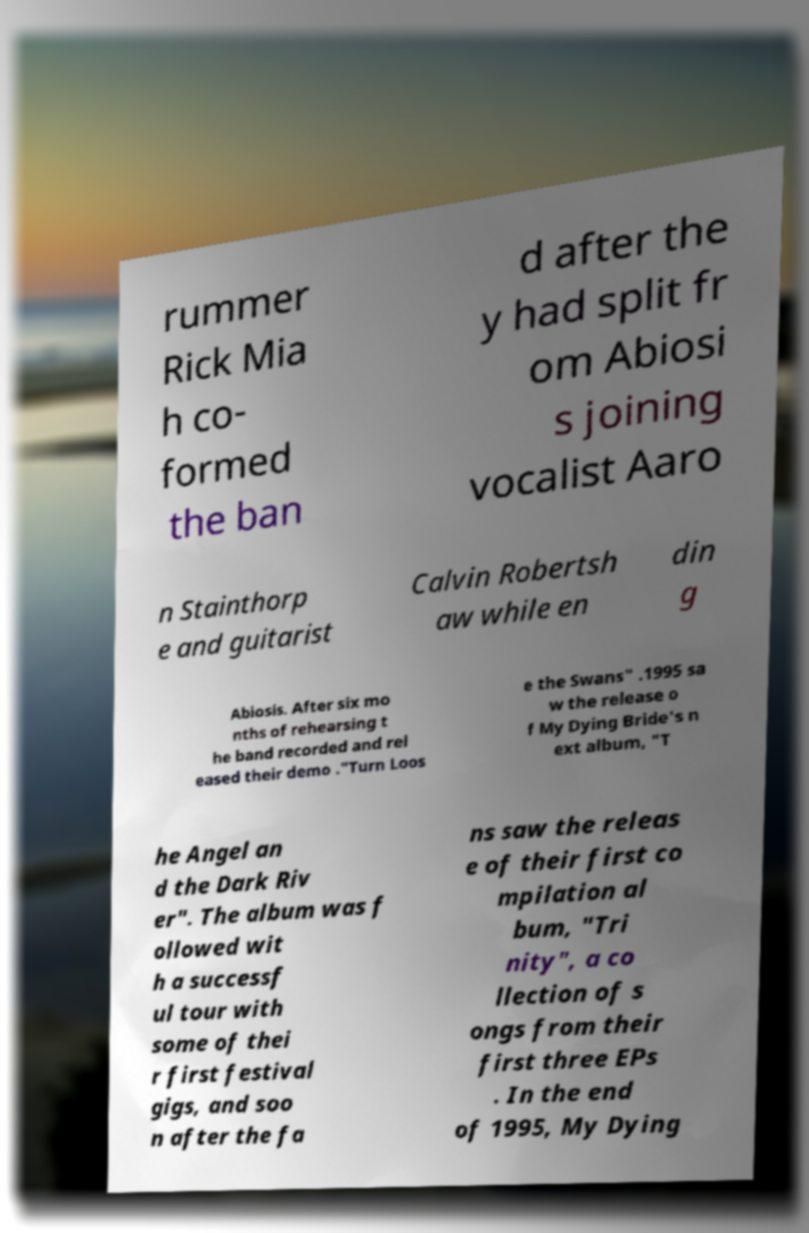Can you accurately transcribe the text from the provided image for me? rummer Rick Mia h co- formed the ban d after the y had split fr om Abiosi s joining vocalist Aaro n Stainthorp e and guitarist Calvin Robertsh aw while en din g Abiosis. After six mo nths of rehearsing t he band recorded and rel eased their demo ."Turn Loos e the Swans" .1995 sa w the release o f My Dying Bride's n ext album, "T he Angel an d the Dark Riv er". The album was f ollowed wit h a successf ul tour with some of thei r first festival gigs, and soo n after the fa ns saw the releas e of their first co mpilation al bum, "Tri nity", a co llection of s ongs from their first three EPs . In the end of 1995, My Dying 